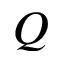<formula> <loc_0><loc_0><loc_500><loc_500>Q</formula> 